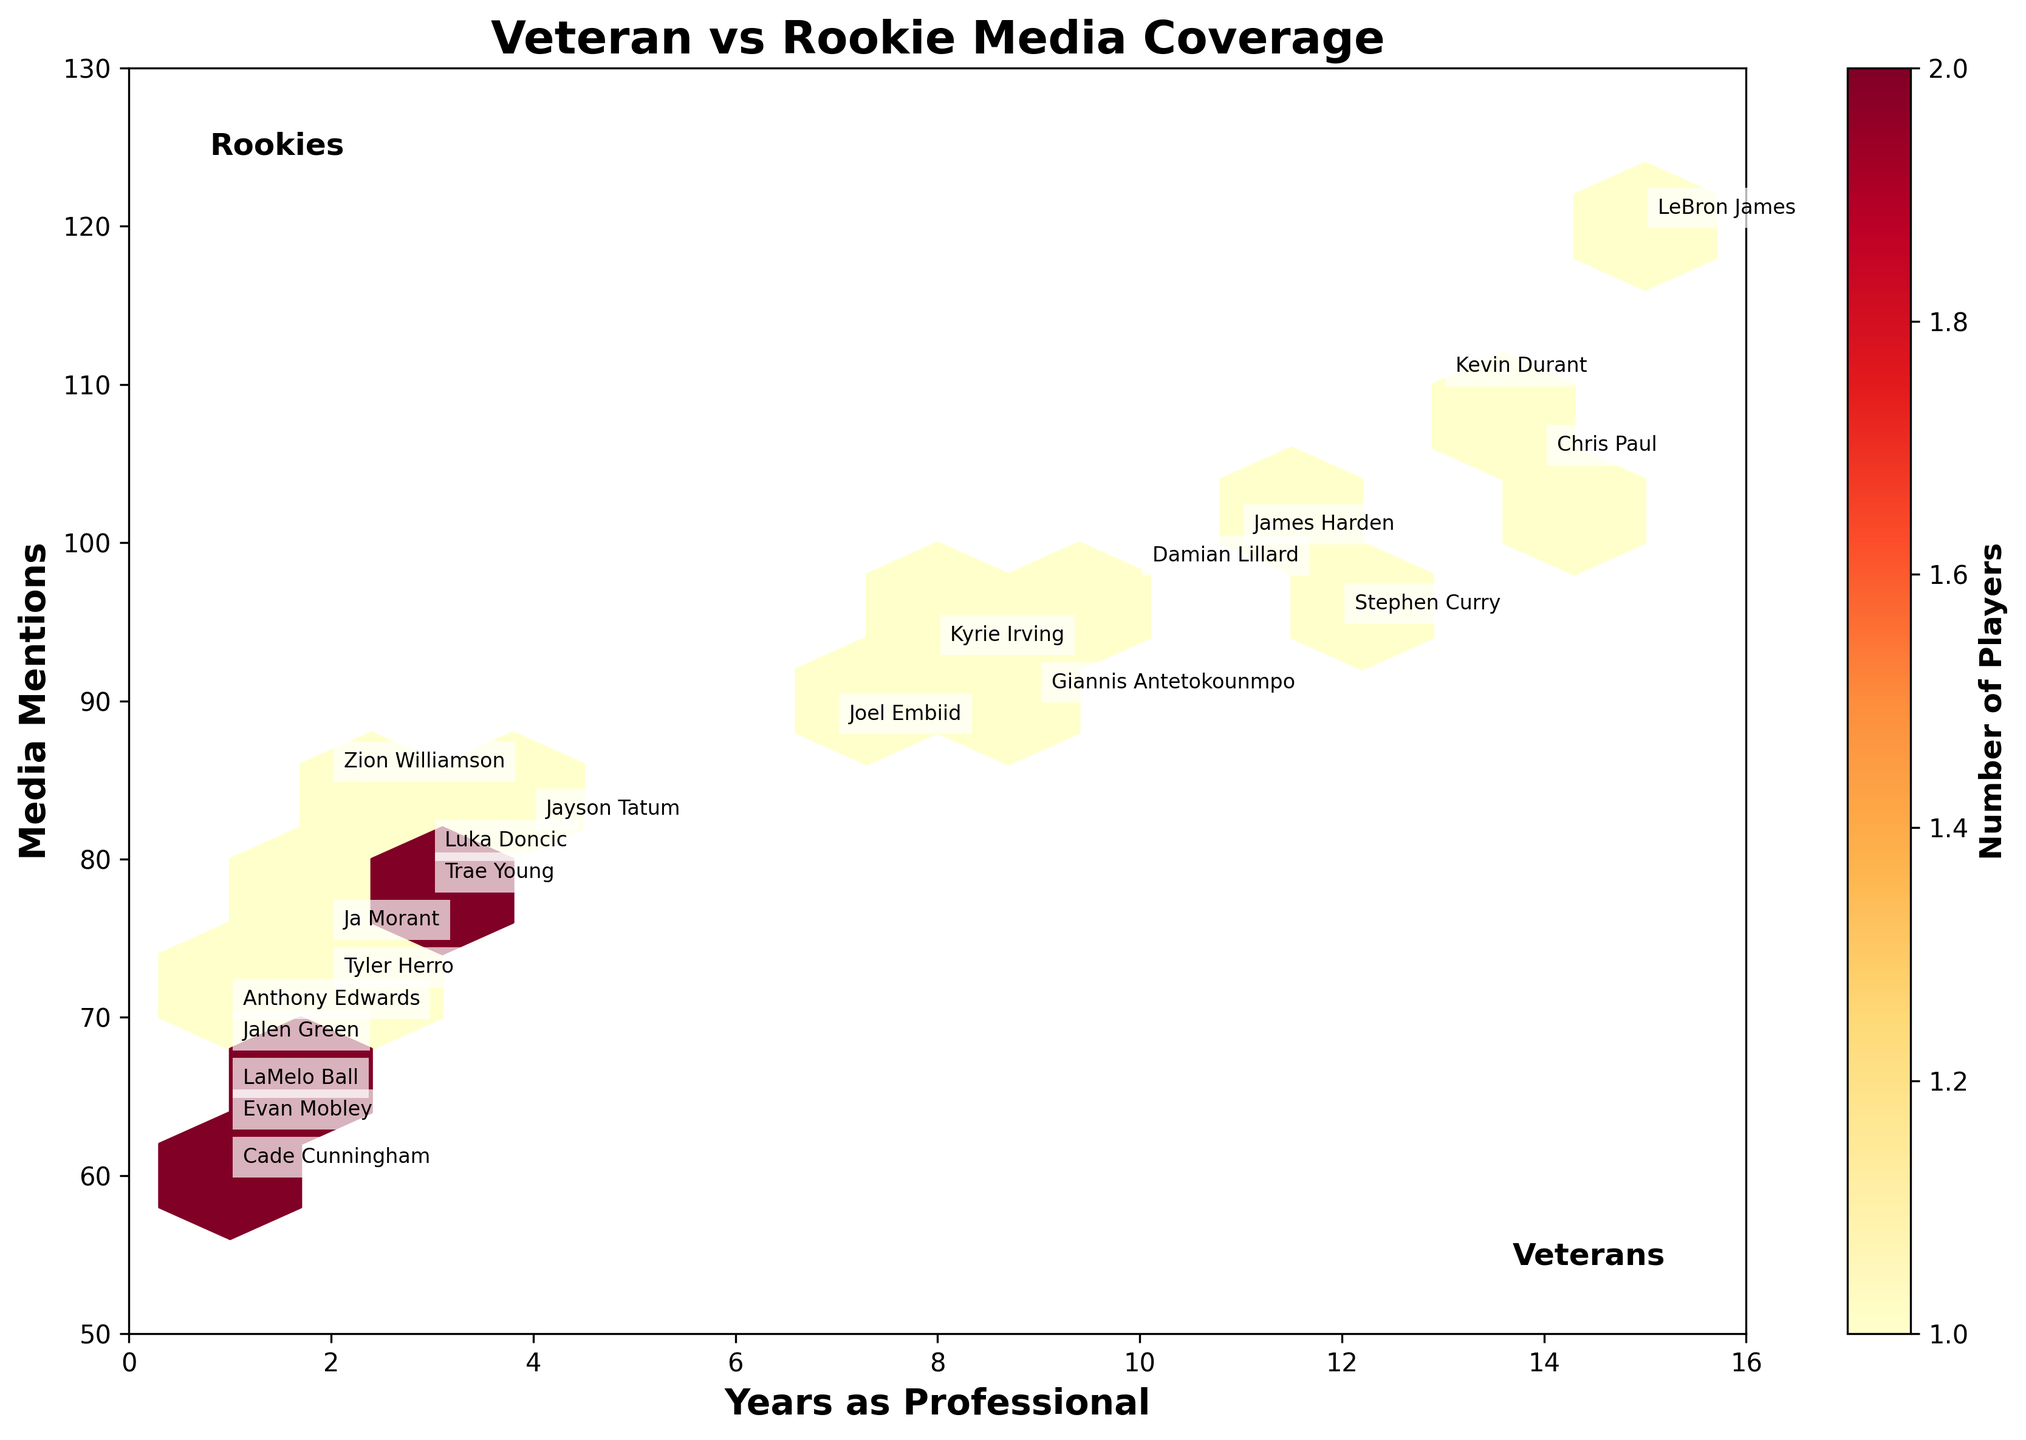What's the title of the plot? The title is typically found at the top of a plot and provides an overview of what the plot is illustrating.
Answer: Veteran vs Rookie Media Coverage What is the range of the x-axis? The range of the x-axis can be determined by looking at the minimum and maximum values specified on that axis. In this plot, it ranges from 0 to 16, corresponding to 'Years as Professional'.
Answer: 0 to 16 What is the color used for the hexagons in the plot? The color scheme for the hexagons is specified in the colormap ('YlOrRd'), which means yellow to red shades are used.
Answer: Yellow to Red What information does the color bar represent? The color bar usually provides a legend for the color intensity in the hexagons, indicating the count of players within each hexbin. The label on the color bar is 'Number of Players'.
Answer: Number of Players Which player has the most media mentions and how many do they have? To find this, you need to look at the highest 'Media Mentions' value annotated beside the player's name on the plot. LeBron James has the most media mentions with 120.
Answer: LeBron James with 120 In which year range is the highest density of players found? The density can be determined by the color intensity in the hexagons. The range where the hexagons are the darkest indicates the highest density.
Answer: Approximately 1-3 years Identify two rookies (1 year pro) with more than 60 media mentions. By looking at the plot annotations for the players with 'Years_Pro' of 1, Anthony Edwards and LaMelo Ball are visible with more than 60 media mentions.
Answer: Anthony Edwards, LaMelo Ball How does media coverage trend compare for players with over 10 years' experience versus those with under 5 years? This requires observing the hexagons' shading and density, which reveal that players with more than 10 years' experience like LeBron James, Chris Paul, and Kevin Durant have higher media mentions compared to players with under 5 years' experience.
Answer: More media mentions for veterans What player is annotated at approximately the midpoint in terms of 'Years as Professional'? The midpoint of 0 to 16 years is around 8 years. Kyrie Irving, with 8 years as a professional, is the player annotated approximately at this midpoint.
Answer: Kyrie Irving How many players have more than 100 media mentions? Refer to the annotations on the plot. By inspecting, you find that LeBron James, Kevin Durant, Chris Paul, and possibly one or two others total more than 100 media mentions. Count their occurrences.
Answer: 4 players 